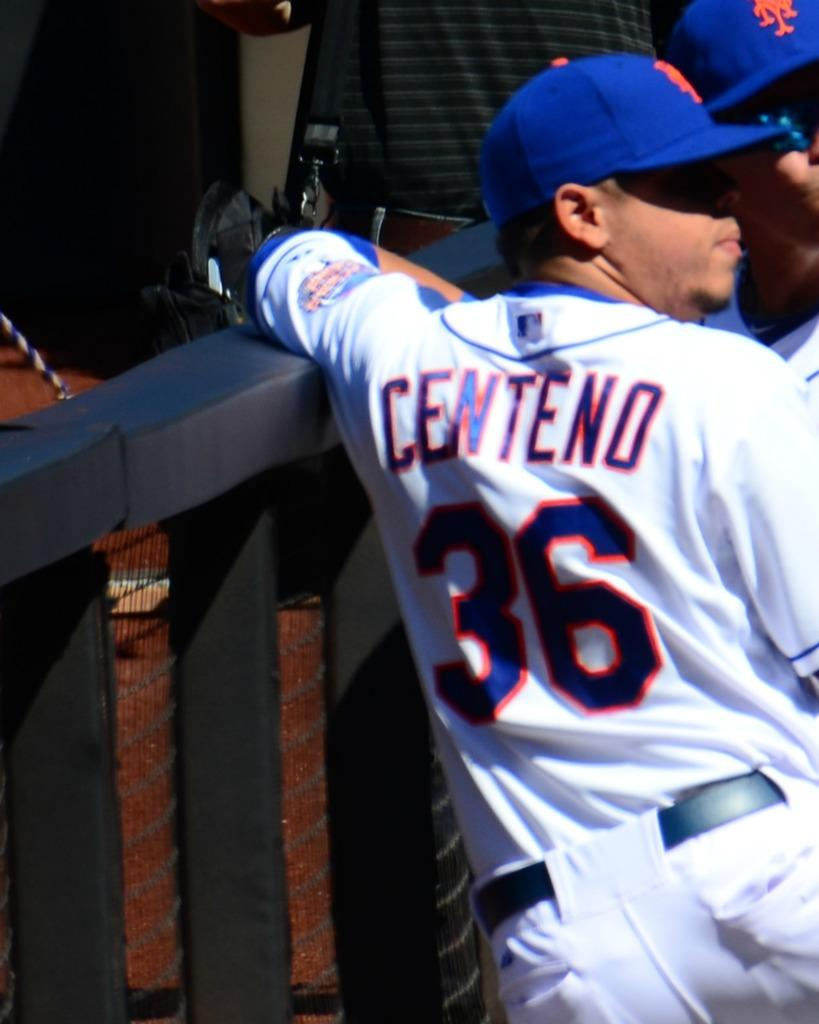<image>
Present a compact description of the photo's key features. Player 36, Centeno, stands against a wall with another teammate. 